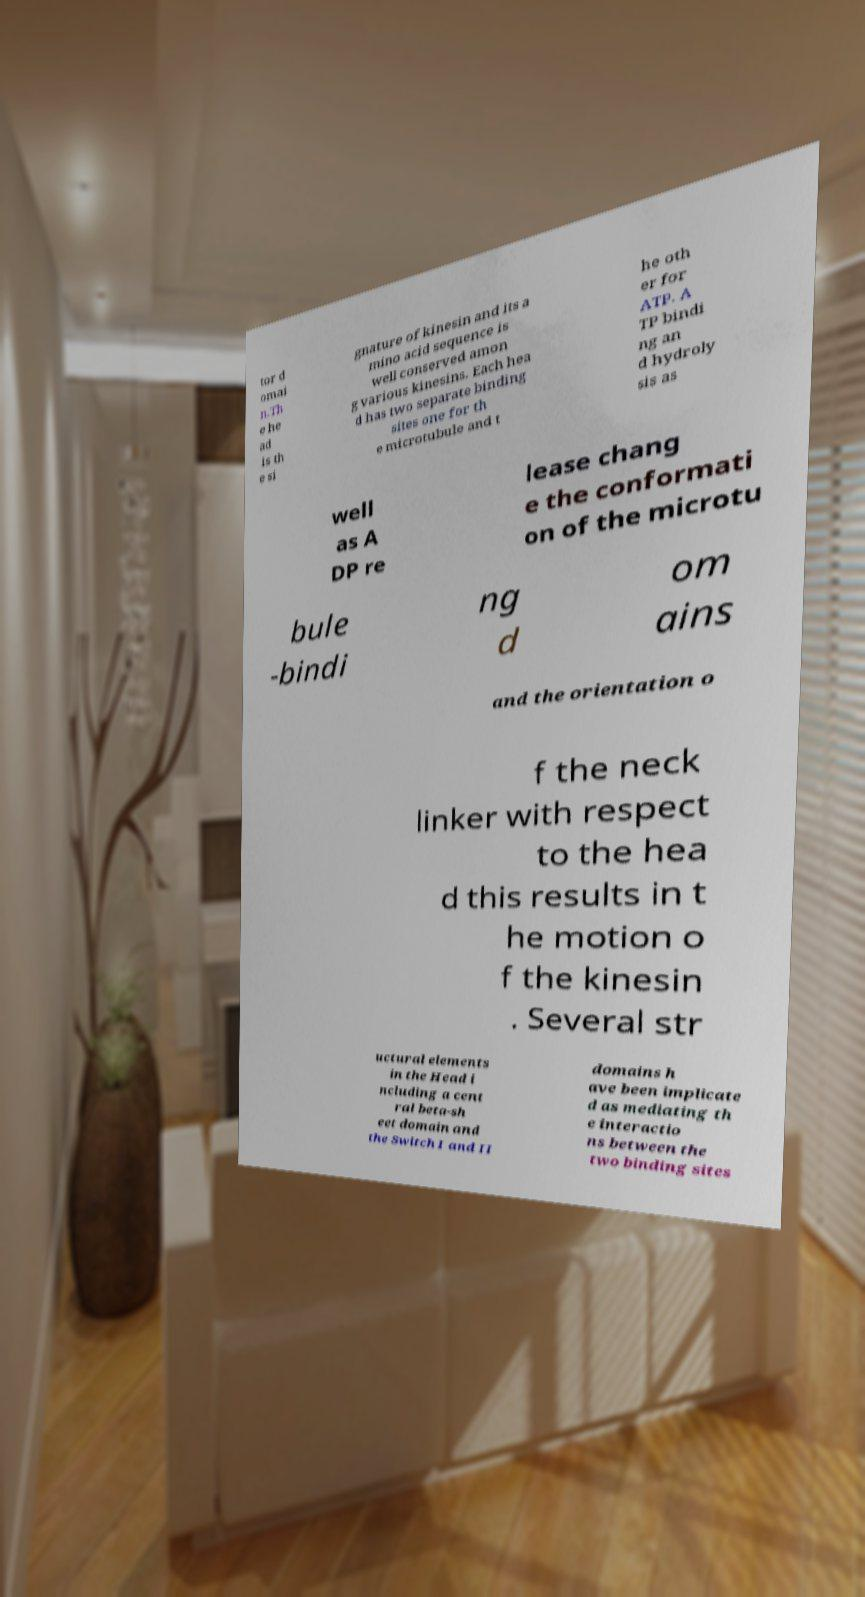I need the written content from this picture converted into text. Can you do that? tor d omai n.Th e he ad is th e si gnature of kinesin and its a mino acid sequence is well conserved amon g various kinesins. Each hea d has two separate binding sites one for th e microtubule and t he oth er for ATP. A TP bindi ng an d hydroly sis as well as A DP re lease chang e the conformati on of the microtu bule -bindi ng d om ains and the orientation o f the neck linker with respect to the hea d this results in t he motion o f the kinesin . Several str uctural elements in the Head i ncluding a cent ral beta-sh eet domain and the Switch I and II domains h ave been implicate d as mediating th e interactio ns between the two binding sites 